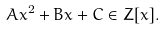<formula> <loc_0><loc_0><loc_500><loc_500>A x ^ { 2 } + B x + C \in Z [ x ] .</formula> 